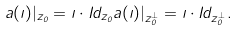<formula> <loc_0><loc_0><loc_500><loc_500>a ( \zeta ) | _ { z _ { 0 } } = \zeta \cdot I d _ { z _ { 0 } } a ( \zeta ) | _ { z _ { 0 } ^ { \bot } } = \zeta \cdot I d _ { z _ { 0 } ^ { \bot } } .</formula> 